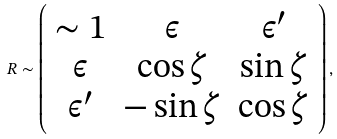Convert formula to latex. <formula><loc_0><loc_0><loc_500><loc_500>R \sim \left ( \begin{array} { c c c } \sim 1 & \epsilon & \epsilon ^ { \prime } \\ \epsilon & \cos \zeta & \sin \zeta \\ \epsilon ^ { \prime } & - \sin \zeta & \cos \zeta \end{array} \right ) ,</formula> 